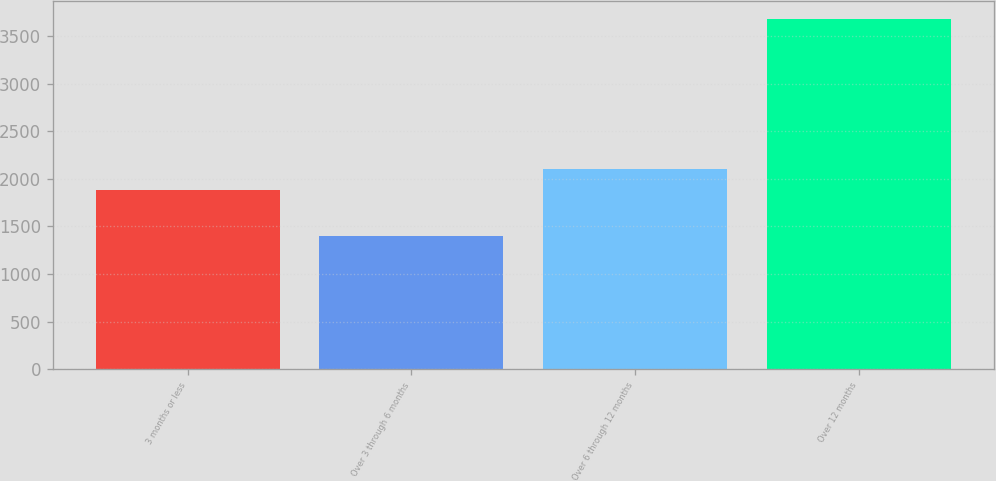Convert chart. <chart><loc_0><loc_0><loc_500><loc_500><bar_chart><fcel>3 months or less<fcel>Over 3 through 6 months<fcel>Over 6 through 12 months<fcel>Over 12 months<nl><fcel>1878<fcel>1396<fcel>2106.3<fcel>3679<nl></chart> 